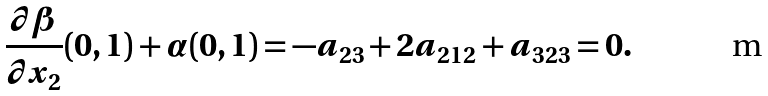<formula> <loc_0><loc_0><loc_500><loc_500>\frac { \partial { \beta } } { \partial { x _ { 2 } } } ( 0 , 1 ) + \alpha ( 0 , 1 ) = - a _ { 2 3 } + 2 a _ { 2 1 2 } + a _ { 3 2 3 } = 0 .</formula> 